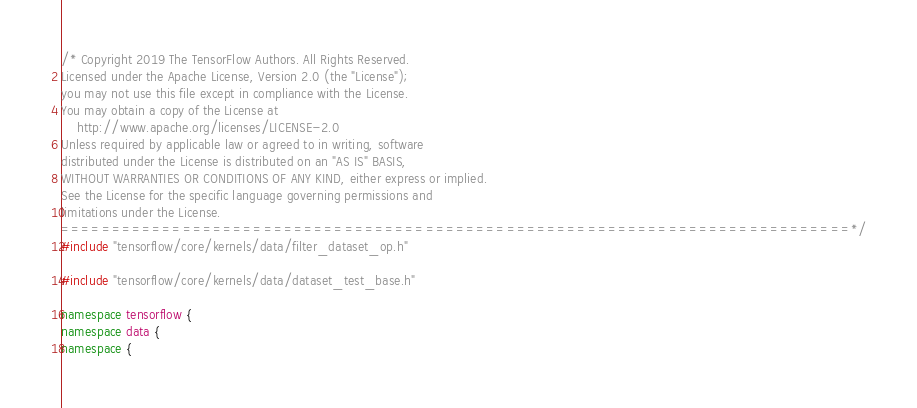Convert code to text. <code><loc_0><loc_0><loc_500><loc_500><_C++_>/* Copyright 2019 The TensorFlow Authors. All Rights Reserved.
Licensed under the Apache License, Version 2.0 (the "License");
you may not use this file except in compliance with the License.
You may obtain a copy of the License at
    http://www.apache.org/licenses/LICENSE-2.0
Unless required by applicable law or agreed to in writing, software
distributed under the License is distributed on an "AS IS" BASIS,
WITHOUT WARRANTIES OR CONDITIONS OF ANY KIND, either express or implied.
See the License for the specific language governing permissions and
limitations under the License.
==============================================================================*/
#include "tensorflow/core/kernels/data/filter_dataset_op.h"

#include "tensorflow/core/kernels/data/dataset_test_base.h"

namespace tensorflow {
namespace data {
namespace {
</code> 